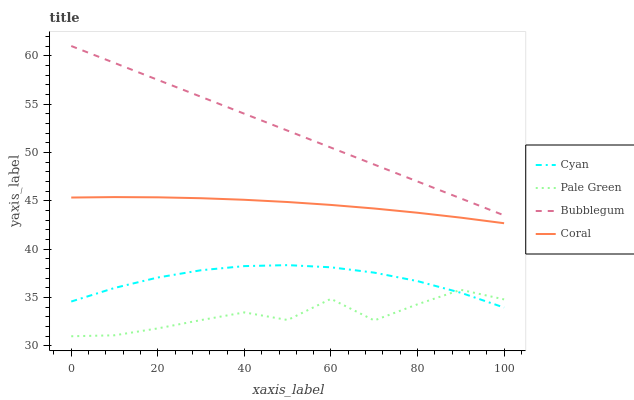Does Pale Green have the minimum area under the curve?
Answer yes or no. Yes. Does Bubblegum have the maximum area under the curve?
Answer yes or no. Yes. Does Coral have the minimum area under the curve?
Answer yes or no. No. Does Coral have the maximum area under the curve?
Answer yes or no. No. Is Bubblegum the smoothest?
Answer yes or no. Yes. Is Pale Green the roughest?
Answer yes or no. Yes. Is Coral the smoothest?
Answer yes or no. No. Is Coral the roughest?
Answer yes or no. No. Does Pale Green have the lowest value?
Answer yes or no. Yes. Does Coral have the lowest value?
Answer yes or no. No. Does Bubblegum have the highest value?
Answer yes or no. Yes. Does Coral have the highest value?
Answer yes or no. No. Is Cyan less than Bubblegum?
Answer yes or no. Yes. Is Bubblegum greater than Coral?
Answer yes or no. Yes. Does Cyan intersect Pale Green?
Answer yes or no. Yes. Is Cyan less than Pale Green?
Answer yes or no. No. Is Cyan greater than Pale Green?
Answer yes or no. No. Does Cyan intersect Bubblegum?
Answer yes or no. No. 